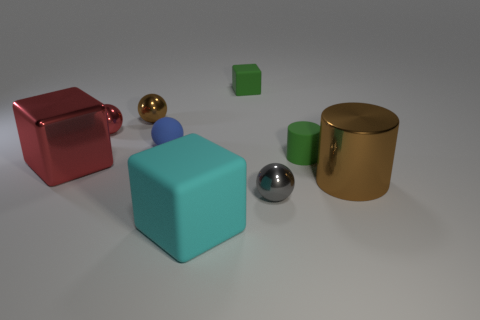Subtract all blue rubber spheres. How many spheres are left? 3 Subtract all blue spheres. How many spheres are left? 3 Subtract all cylinders. How many objects are left? 7 Subtract all red cylinders. Subtract all yellow blocks. How many cylinders are left? 2 Subtract all blue cubes. How many green cylinders are left? 1 Subtract all red blocks. Subtract all green cylinders. How many objects are left? 7 Add 5 brown spheres. How many brown spheres are left? 6 Add 4 large green matte cubes. How many large green matte cubes exist? 4 Add 1 small yellow matte cylinders. How many objects exist? 10 Subtract 0 gray cylinders. How many objects are left? 9 